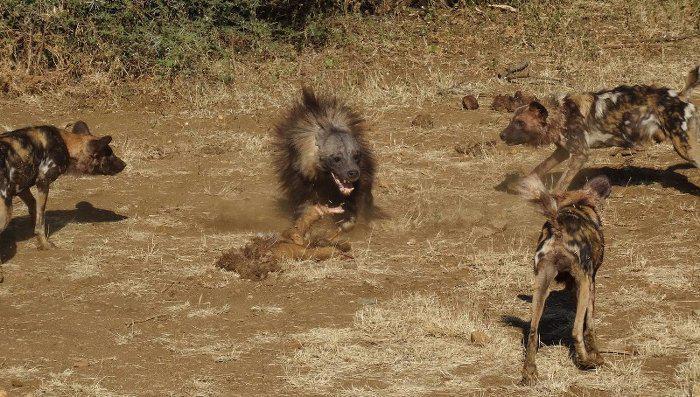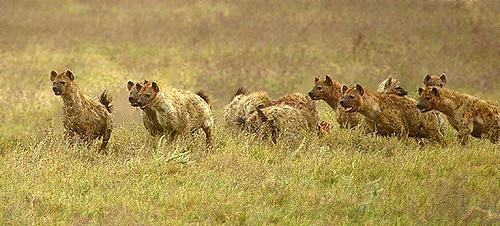The first image is the image on the left, the second image is the image on the right. Examine the images to the left and right. Is the description "An image shows an animal with fangs bared surrounded by hyenas." accurate? Answer yes or no. Yes. 